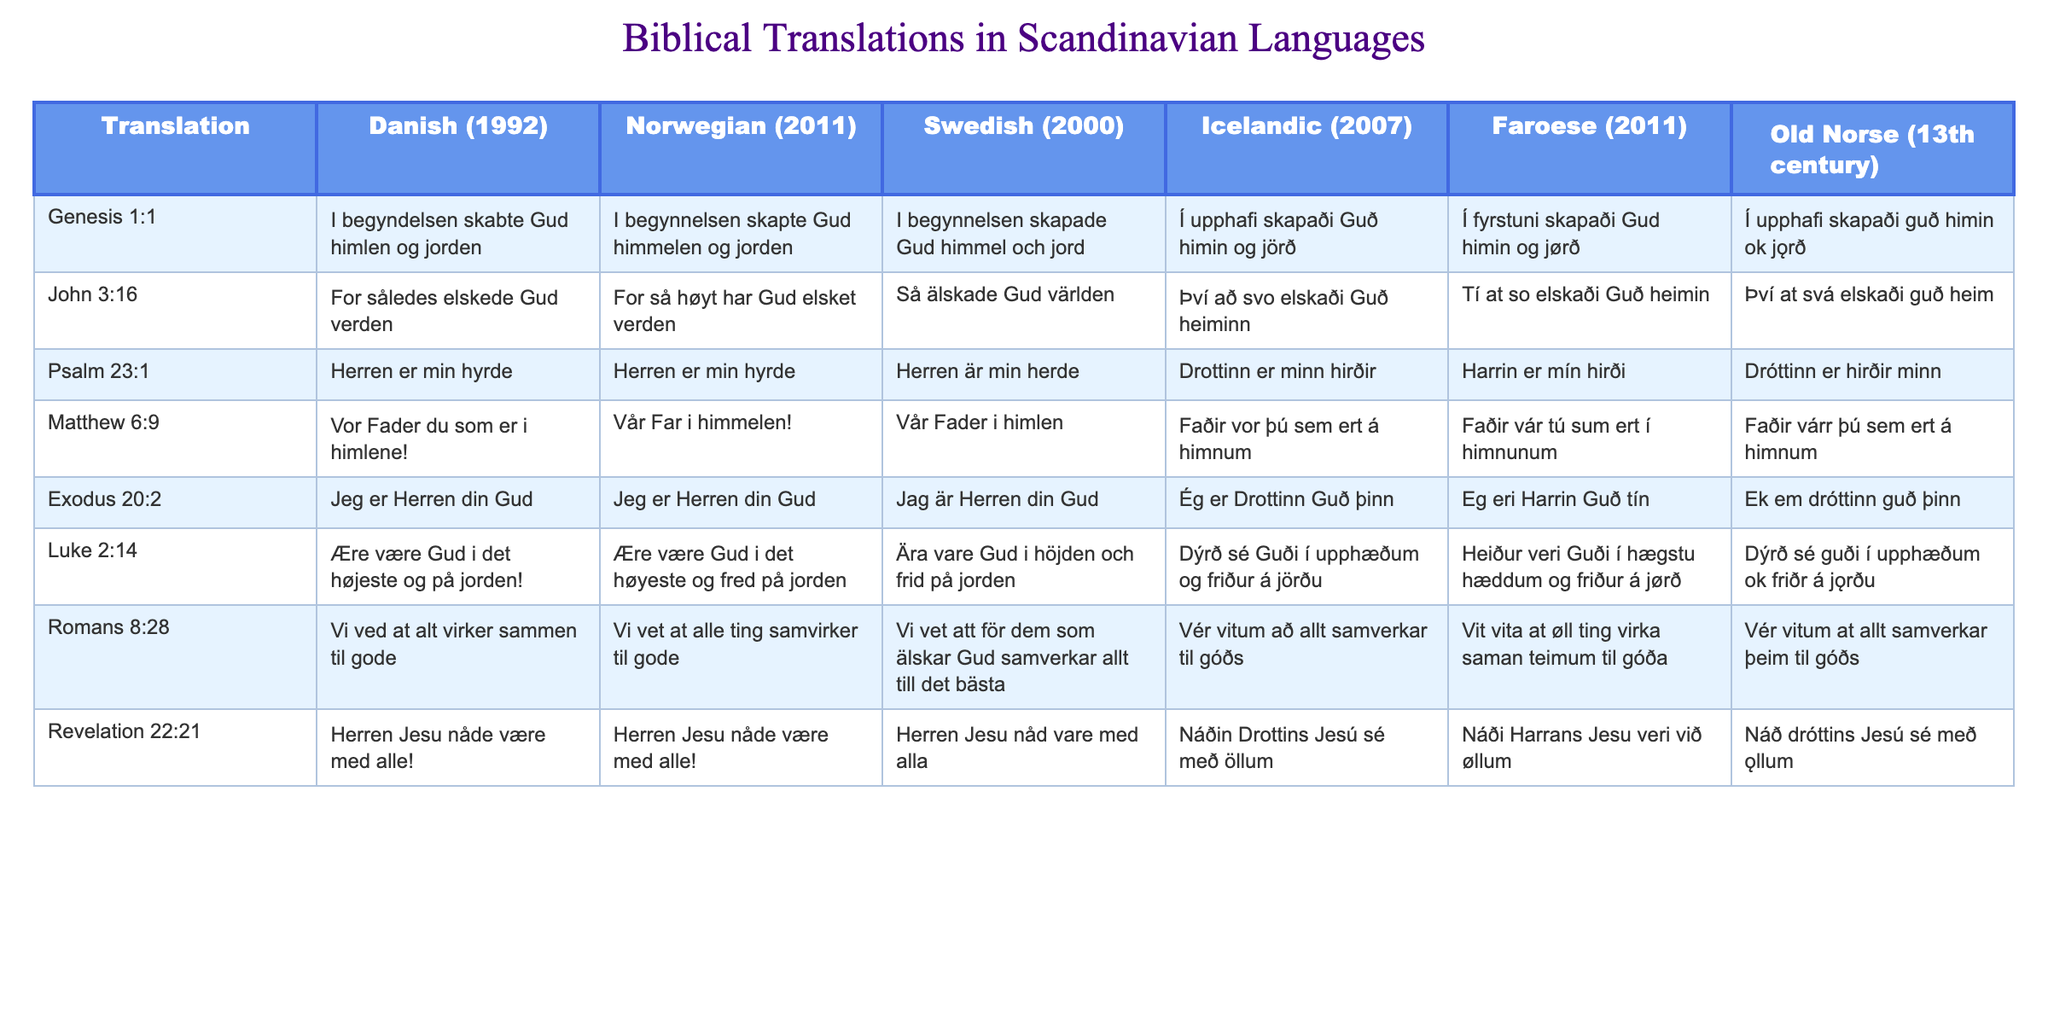What is the Danish translation of John 3:16? The table shows that the Danish translation for John 3:16 is "For således elskede Gud verden."
Answer: For således elskede Gud verden Which verse has the same wording in both Norwegian and Danish? By comparing the rows in the table, Psalm 23:1 has identical wording in both the Norwegian and Danish columns: "Herren er min hyrde."
Answer: Psalm 23:1 Is there a translation of Genesis 1:1 that differs significantly from the other translations? Looking at the translations in the table, the Old Norse version "Í upphafi skapaði guð himin ok jǫrð" uses different phrasing compared to the more modern translations, suggesting a significant difference.
Answer: Yes What is the most commonly used word translated for "God" across the translations? Upon reviewing the translations, "Gud" appears consistently, while "Guð" is used in the Icelandic translations, indicating similar references. "Gud" is widely used across multiple translations.
Answer: Gud In how many translations is the phrase "Herren" used, and in which verses? Counting the occurrences in the table, "Herren" appears in Psalm 23:1, Matthew 6:9, and Revelation 22:21, which totals to three instances.
Answer: Three translations Which verse has the longest translation in Icelandic? By examining the table, Luke 2:14 has the longest translation in Icelandic: "Dýrð sé Guði í upphæðum og friður á jörðu."
Answer: Luke 2:14 What is the average length of translations for Exodus 20:2 across the Scandinavian languages? Evaluating the lengths of each translation listed in the table for Exodus 20:2: Danish - 23, Norwegian - 23, Swedish - 23, Icelandic - 20, Faroese - 20, and Old Norse - 22. The average length is calculated as (23 + 23 + 23 + 20 + 20 + 22) / 6 = 22.
Answer: 22 words Do all versions of the phrase "Herren Jesu" have the same wording in Danish and Norwegian? By reviewing the translations, both the Danish and Norwegian versions of Revelation 22:21 state "Herren Jesu nåde være med alle!" confirming they are identical.
Answer: Yes Which verse shows a translation change of "peace" in Swedish versus Norwegian and Danish? The phrase "fred" in the Swedish translation of Luke 2:14 differs from "fred" in the Norwegian, while Danish uses "på jorden" confirming the translation change in context.
Answer: Luke 2:14 Is the phrase "som er" present in both the Swedish and the Danish translations? The Danish translation for Matthew 6:9 includes "du som er," while the Swedish translation directly represents "i himlen." They don't share the same phrase structure.
Answer: No 